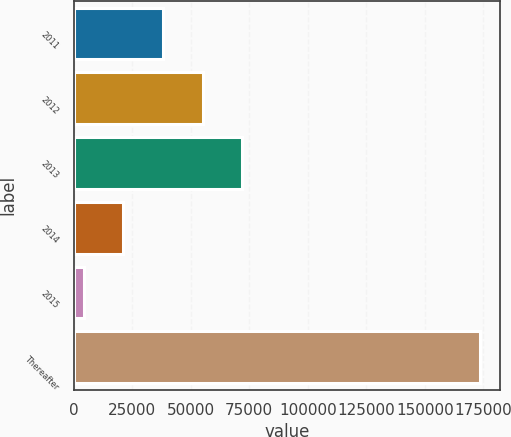<chart> <loc_0><loc_0><loc_500><loc_500><bar_chart><fcel>2011<fcel>2012<fcel>2013<fcel>2014<fcel>2015<fcel>Thereafter<nl><fcel>38226.4<fcel>55151.1<fcel>72075.8<fcel>21301.7<fcel>4377<fcel>173624<nl></chart> 